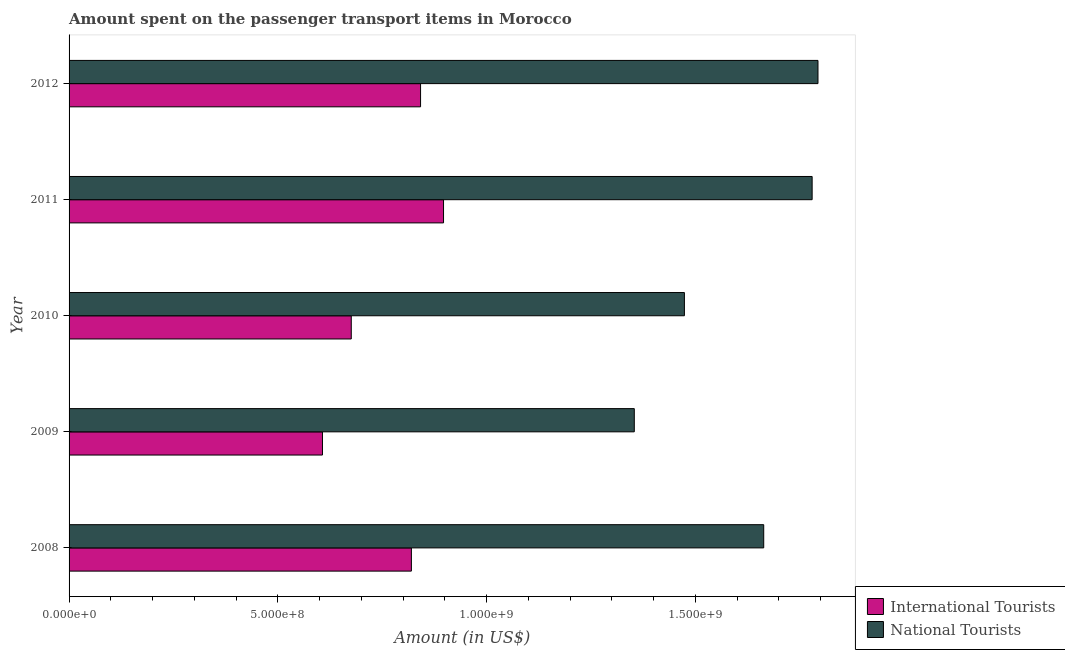How many groups of bars are there?
Your answer should be compact. 5. How many bars are there on the 5th tick from the bottom?
Your answer should be very brief. 2. What is the label of the 1st group of bars from the top?
Keep it short and to the point. 2012. What is the amount spent on transport items of national tourists in 2009?
Ensure brevity in your answer.  1.35e+09. Across all years, what is the maximum amount spent on transport items of national tourists?
Your answer should be compact. 1.79e+09. Across all years, what is the minimum amount spent on transport items of international tourists?
Your response must be concise. 6.07e+08. In which year was the amount spent on transport items of national tourists maximum?
Provide a short and direct response. 2012. In which year was the amount spent on transport items of national tourists minimum?
Offer a very short reply. 2009. What is the total amount spent on transport items of national tourists in the graph?
Provide a short and direct response. 8.07e+09. What is the difference between the amount spent on transport items of national tourists in 2009 and that in 2012?
Offer a terse response. -4.40e+08. What is the difference between the amount spent on transport items of national tourists in 2012 and the amount spent on transport items of international tourists in 2009?
Keep it short and to the point. 1.19e+09. What is the average amount spent on transport items of national tourists per year?
Give a very brief answer. 1.61e+09. In the year 2009, what is the difference between the amount spent on transport items of international tourists and amount spent on transport items of national tourists?
Give a very brief answer. -7.47e+08. What is the ratio of the amount spent on transport items of national tourists in 2010 to that in 2011?
Provide a short and direct response. 0.83. Is the amount spent on transport items of national tourists in 2008 less than that in 2010?
Offer a very short reply. No. What is the difference between the highest and the second highest amount spent on transport items of national tourists?
Offer a very short reply. 1.40e+07. What is the difference between the highest and the lowest amount spent on transport items of international tourists?
Offer a terse response. 2.90e+08. In how many years, is the amount spent on transport items of international tourists greater than the average amount spent on transport items of international tourists taken over all years?
Your answer should be very brief. 3. Is the sum of the amount spent on transport items of international tourists in 2008 and 2009 greater than the maximum amount spent on transport items of national tourists across all years?
Give a very brief answer. No. What does the 1st bar from the top in 2008 represents?
Provide a succinct answer. National Tourists. What does the 2nd bar from the bottom in 2009 represents?
Your answer should be very brief. National Tourists. Are all the bars in the graph horizontal?
Make the answer very short. Yes. Does the graph contain any zero values?
Your response must be concise. No. How are the legend labels stacked?
Provide a succinct answer. Vertical. What is the title of the graph?
Provide a short and direct response. Amount spent on the passenger transport items in Morocco. What is the label or title of the X-axis?
Keep it short and to the point. Amount (in US$). What is the label or title of the Y-axis?
Make the answer very short. Year. What is the Amount (in US$) in International Tourists in 2008?
Provide a short and direct response. 8.20e+08. What is the Amount (in US$) in National Tourists in 2008?
Offer a terse response. 1.66e+09. What is the Amount (in US$) in International Tourists in 2009?
Your response must be concise. 6.07e+08. What is the Amount (in US$) in National Tourists in 2009?
Your answer should be compact. 1.35e+09. What is the Amount (in US$) of International Tourists in 2010?
Provide a succinct answer. 6.76e+08. What is the Amount (in US$) of National Tourists in 2010?
Your response must be concise. 1.47e+09. What is the Amount (in US$) in International Tourists in 2011?
Ensure brevity in your answer.  8.97e+08. What is the Amount (in US$) in National Tourists in 2011?
Offer a terse response. 1.78e+09. What is the Amount (in US$) of International Tourists in 2012?
Offer a terse response. 8.42e+08. What is the Amount (in US$) in National Tourists in 2012?
Provide a short and direct response. 1.79e+09. Across all years, what is the maximum Amount (in US$) of International Tourists?
Your answer should be compact. 8.97e+08. Across all years, what is the maximum Amount (in US$) of National Tourists?
Offer a terse response. 1.79e+09. Across all years, what is the minimum Amount (in US$) in International Tourists?
Give a very brief answer. 6.07e+08. Across all years, what is the minimum Amount (in US$) in National Tourists?
Your answer should be compact. 1.35e+09. What is the total Amount (in US$) in International Tourists in the graph?
Provide a short and direct response. 3.84e+09. What is the total Amount (in US$) in National Tourists in the graph?
Keep it short and to the point. 8.07e+09. What is the difference between the Amount (in US$) in International Tourists in 2008 and that in 2009?
Provide a short and direct response. 2.13e+08. What is the difference between the Amount (in US$) of National Tourists in 2008 and that in 2009?
Offer a terse response. 3.10e+08. What is the difference between the Amount (in US$) of International Tourists in 2008 and that in 2010?
Your answer should be compact. 1.44e+08. What is the difference between the Amount (in US$) in National Tourists in 2008 and that in 2010?
Offer a terse response. 1.90e+08. What is the difference between the Amount (in US$) of International Tourists in 2008 and that in 2011?
Offer a very short reply. -7.70e+07. What is the difference between the Amount (in US$) of National Tourists in 2008 and that in 2011?
Provide a short and direct response. -1.16e+08. What is the difference between the Amount (in US$) of International Tourists in 2008 and that in 2012?
Make the answer very short. -2.20e+07. What is the difference between the Amount (in US$) of National Tourists in 2008 and that in 2012?
Ensure brevity in your answer.  -1.30e+08. What is the difference between the Amount (in US$) in International Tourists in 2009 and that in 2010?
Your answer should be compact. -6.90e+07. What is the difference between the Amount (in US$) of National Tourists in 2009 and that in 2010?
Offer a terse response. -1.20e+08. What is the difference between the Amount (in US$) in International Tourists in 2009 and that in 2011?
Offer a terse response. -2.90e+08. What is the difference between the Amount (in US$) of National Tourists in 2009 and that in 2011?
Provide a short and direct response. -4.26e+08. What is the difference between the Amount (in US$) in International Tourists in 2009 and that in 2012?
Provide a succinct answer. -2.35e+08. What is the difference between the Amount (in US$) of National Tourists in 2009 and that in 2012?
Your response must be concise. -4.40e+08. What is the difference between the Amount (in US$) in International Tourists in 2010 and that in 2011?
Your answer should be very brief. -2.21e+08. What is the difference between the Amount (in US$) in National Tourists in 2010 and that in 2011?
Your answer should be very brief. -3.06e+08. What is the difference between the Amount (in US$) of International Tourists in 2010 and that in 2012?
Offer a very short reply. -1.66e+08. What is the difference between the Amount (in US$) in National Tourists in 2010 and that in 2012?
Keep it short and to the point. -3.20e+08. What is the difference between the Amount (in US$) of International Tourists in 2011 and that in 2012?
Your answer should be compact. 5.50e+07. What is the difference between the Amount (in US$) of National Tourists in 2011 and that in 2012?
Offer a terse response. -1.40e+07. What is the difference between the Amount (in US$) of International Tourists in 2008 and the Amount (in US$) of National Tourists in 2009?
Ensure brevity in your answer.  -5.34e+08. What is the difference between the Amount (in US$) in International Tourists in 2008 and the Amount (in US$) in National Tourists in 2010?
Give a very brief answer. -6.54e+08. What is the difference between the Amount (in US$) in International Tourists in 2008 and the Amount (in US$) in National Tourists in 2011?
Offer a terse response. -9.60e+08. What is the difference between the Amount (in US$) of International Tourists in 2008 and the Amount (in US$) of National Tourists in 2012?
Keep it short and to the point. -9.74e+08. What is the difference between the Amount (in US$) in International Tourists in 2009 and the Amount (in US$) in National Tourists in 2010?
Offer a terse response. -8.67e+08. What is the difference between the Amount (in US$) of International Tourists in 2009 and the Amount (in US$) of National Tourists in 2011?
Provide a short and direct response. -1.17e+09. What is the difference between the Amount (in US$) in International Tourists in 2009 and the Amount (in US$) in National Tourists in 2012?
Provide a succinct answer. -1.19e+09. What is the difference between the Amount (in US$) of International Tourists in 2010 and the Amount (in US$) of National Tourists in 2011?
Offer a terse response. -1.10e+09. What is the difference between the Amount (in US$) in International Tourists in 2010 and the Amount (in US$) in National Tourists in 2012?
Keep it short and to the point. -1.12e+09. What is the difference between the Amount (in US$) in International Tourists in 2011 and the Amount (in US$) in National Tourists in 2012?
Provide a short and direct response. -8.97e+08. What is the average Amount (in US$) of International Tourists per year?
Keep it short and to the point. 7.68e+08. What is the average Amount (in US$) of National Tourists per year?
Provide a short and direct response. 1.61e+09. In the year 2008, what is the difference between the Amount (in US$) of International Tourists and Amount (in US$) of National Tourists?
Offer a very short reply. -8.44e+08. In the year 2009, what is the difference between the Amount (in US$) in International Tourists and Amount (in US$) in National Tourists?
Offer a terse response. -7.47e+08. In the year 2010, what is the difference between the Amount (in US$) in International Tourists and Amount (in US$) in National Tourists?
Make the answer very short. -7.98e+08. In the year 2011, what is the difference between the Amount (in US$) of International Tourists and Amount (in US$) of National Tourists?
Provide a succinct answer. -8.83e+08. In the year 2012, what is the difference between the Amount (in US$) in International Tourists and Amount (in US$) in National Tourists?
Offer a terse response. -9.52e+08. What is the ratio of the Amount (in US$) in International Tourists in 2008 to that in 2009?
Your answer should be compact. 1.35. What is the ratio of the Amount (in US$) of National Tourists in 2008 to that in 2009?
Offer a very short reply. 1.23. What is the ratio of the Amount (in US$) of International Tourists in 2008 to that in 2010?
Provide a succinct answer. 1.21. What is the ratio of the Amount (in US$) in National Tourists in 2008 to that in 2010?
Your response must be concise. 1.13. What is the ratio of the Amount (in US$) in International Tourists in 2008 to that in 2011?
Your answer should be very brief. 0.91. What is the ratio of the Amount (in US$) of National Tourists in 2008 to that in 2011?
Make the answer very short. 0.93. What is the ratio of the Amount (in US$) of International Tourists in 2008 to that in 2012?
Offer a very short reply. 0.97. What is the ratio of the Amount (in US$) in National Tourists in 2008 to that in 2012?
Offer a very short reply. 0.93. What is the ratio of the Amount (in US$) in International Tourists in 2009 to that in 2010?
Provide a succinct answer. 0.9. What is the ratio of the Amount (in US$) of National Tourists in 2009 to that in 2010?
Provide a succinct answer. 0.92. What is the ratio of the Amount (in US$) in International Tourists in 2009 to that in 2011?
Your answer should be very brief. 0.68. What is the ratio of the Amount (in US$) of National Tourists in 2009 to that in 2011?
Your response must be concise. 0.76. What is the ratio of the Amount (in US$) in International Tourists in 2009 to that in 2012?
Ensure brevity in your answer.  0.72. What is the ratio of the Amount (in US$) of National Tourists in 2009 to that in 2012?
Ensure brevity in your answer.  0.75. What is the ratio of the Amount (in US$) of International Tourists in 2010 to that in 2011?
Your answer should be compact. 0.75. What is the ratio of the Amount (in US$) in National Tourists in 2010 to that in 2011?
Give a very brief answer. 0.83. What is the ratio of the Amount (in US$) in International Tourists in 2010 to that in 2012?
Your answer should be compact. 0.8. What is the ratio of the Amount (in US$) of National Tourists in 2010 to that in 2012?
Your answer should be very brief. 0.82. What is the ratio of the Amount (in US$) of International Tourists in 2011 to that in 2012?
Your answer should be compact. 1.07. What is the ratio of the Amount (in US$) of National Tourists in 2011 to that in 2012?
Ensure brevity in your answer.  0.99. What is the difference between the highest and the second highest Amount (in US$) of International Tourists?
Keep it short and to the point. 5.50e+07. What is the difference between the highest and the second highest Amount (in US$) of National Tourists?
Your answer should be very brief. 1.40e+07. What is the difference between the highest and the lowest Amount (in US$) of International Tourists?
Give a very brief answer. 2.90e+08. What is the difference between the highest and the lowest Amount (in US$) of National Tourists?
Provide a succinct answer. 4.40e+08. 